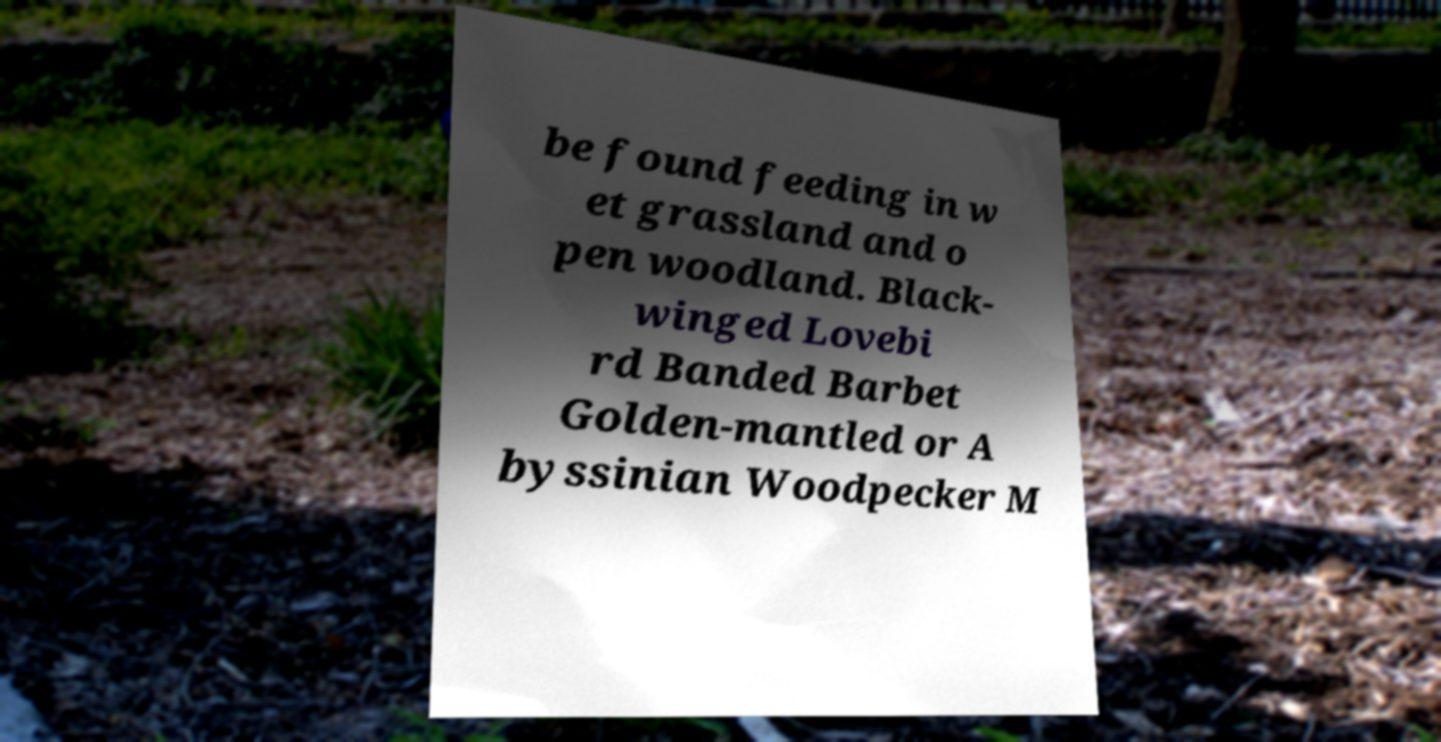Can you accurately transcribe the text from the provided image for me? be found feeding in w et grassland and o pen woodland. Black- winged Lovebi rd Banded Barbet Golden-mantled or A byssinian Woodpecker M 